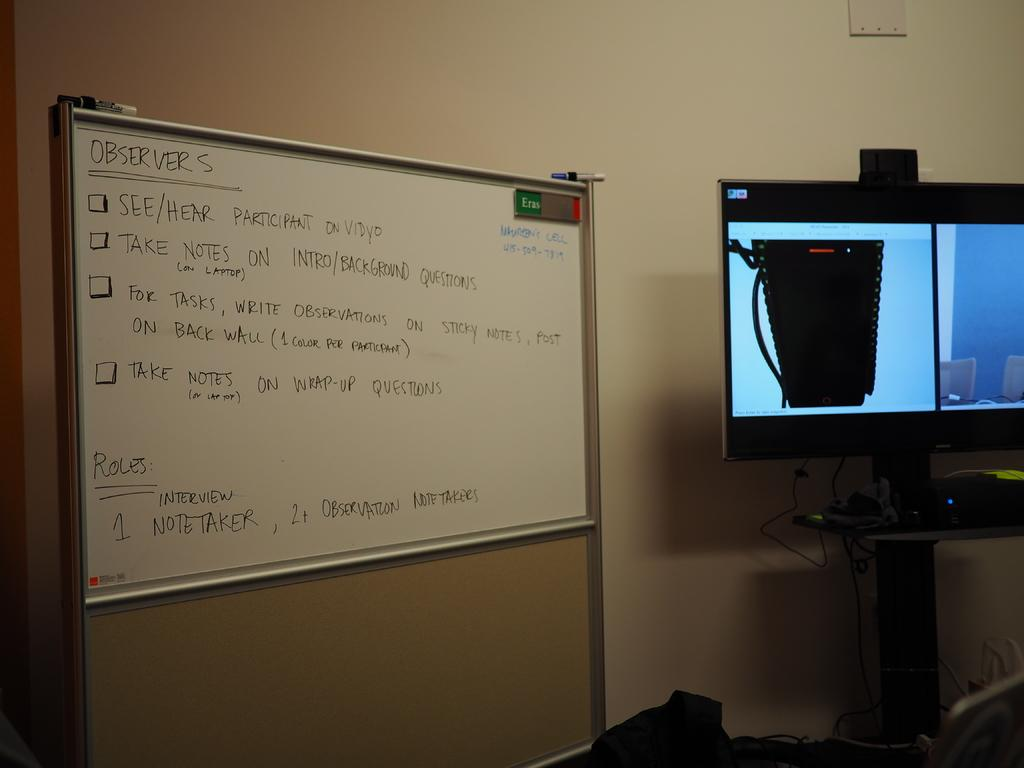<image>
Provide a brief description of the given image. a board that says observer at the top of it 